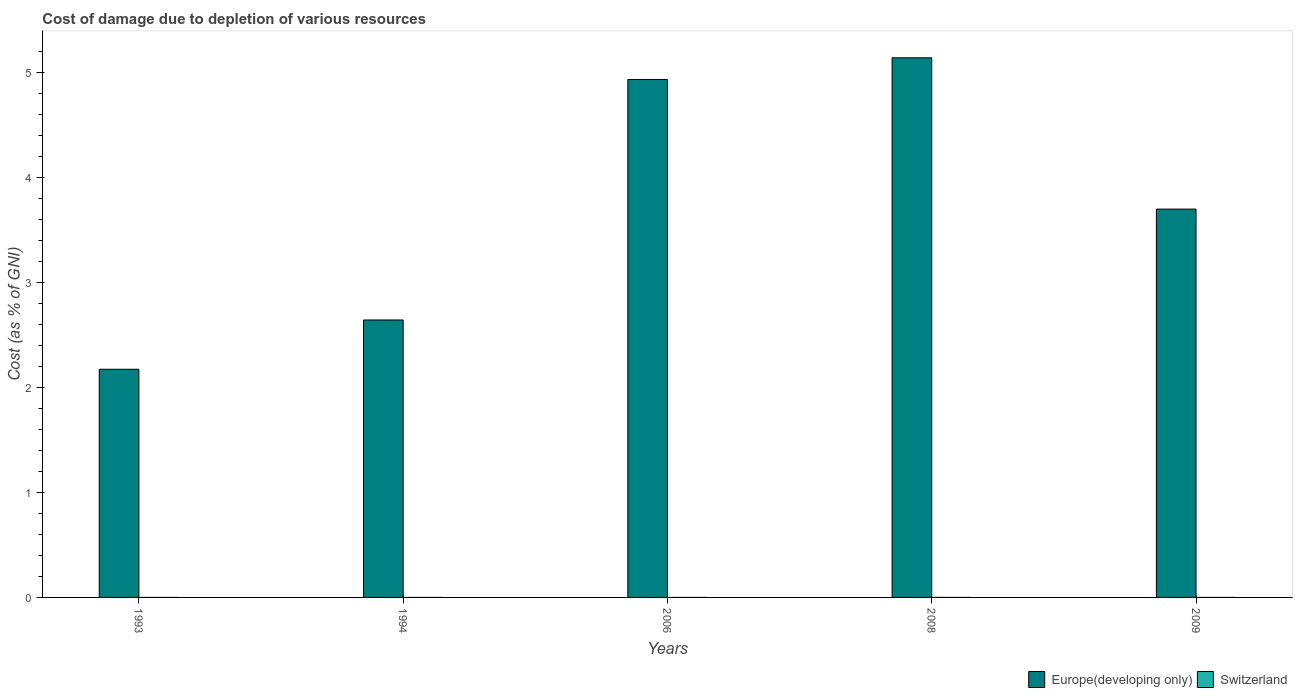Are the number of bars on each tick of the X-axis equal?
Provide a short and direct response. Yes. How many bars are there on the 4th tick from the right?
Ensure brevity in your answer.  2. What is the cost of damage caused due to the depletion of various resources in Switzerland in 1994?
Your response must be concise. 1.30474055829756e-5. Across all years, what is the maximum cost of damage caused due to the depletion of various resources in Switzerland?
Keep it short and to the point. 0. Across all years, what is the minimum cost of damage caused due to the depletion of various resources in Switzerland?
Provide a short and direct response. 1.30474055829756e-5. In which year was the cost of damage caused due to the depletion of various resources in Europe(developing only) minimum?
Provide a short and direct response. 1993. What is the total cost of damage caused due to the depletion of various resources in Europe(developing only) in the graph?
Offer a terse response. 18.57. What is the difference between the cost of damage caused due to the depletion of various resources in Europe(developing only) in 2006 and that in 2009?
Give a very brief answer. 1.23. What is the difference between the cost of damage caused due to the depletion of various resources in Switzerland in 1993 and the cost of damage caused due to the depletion of various resources in Europe(developing only) in 1994?
Your answer should be compact. -2.64. What is the average cost of damage caused due to the depletion of various resources in Europe(developing only) per year?
Give a very brief answer. 3.71. In the year 1993, what is the difference between the cost of damage caused due to the depletion of various resources in Switzerland and cost of damage caused due to the depletion of various resources in Europe(developing only)?
Keep it short and to the point. -2.17. In how many years, is the cost of damage caused due to the depletion of various resources in Switzerland greater than 2.8 %?
Give a very brief answer. 0. What is the ratio of the cost of damage caused due to the depletion of various resources in Switzerland in 1994 to that in 2008?
Provide a succinct answer. 0.09. What is the difference between the highest and the second highest cost of damage caused due to the depletion of various resources in Switzerland?
Provide a short and direct response. 6.766318279774521e-5. What is the difference between the highest and the lowest cost of damage caused due to the depletion of various resources in Switzerland?
Offer a terse response. 0. What does the 2nd bar from the left in 2009 represents?
Make the answer very short. Switzerland. What does the 2nd bar from the right in 1993 represents?
Ensure brevity in your answer.  Europe(developing only). Are all the bars in the graph horizontal?
Offer a terse response. No. What is the difference between two consecutive major ticks on the Y-axis?
Keep it short and to the point. 1. Does the graph contain grids?
Offer a very short reply. No. Where does the legend appear in the graph?
Your answer should be very brief. Bottom right. How many legend labels are there?
Offer a terse response. 2. What is the title of the graph?
Your answer should be compact. Cost of damage due to depletion of various resources. What is the label or title of the Y-axis?
Keep it short and to the point. Cost (as % of GNI). What is the Cost (as % of GNI) of Europe(developing only) in 1993?
Your answer should be very brief. 2.17. What is the Cost (as % of GNI) in Switzerland in 1993?
Offer a terse response. 3.19738165059721e-5. What is the Cost (as % of GNI) in Europe(developing only) in 1994?
Keep it short and to the point. 2.64. What is the Cost (as % of GNI) in Switzerland in 1994?
Your answer should be very brief. 1.30474055829756e-5. What is the Cost (as % of GNI) in Europe(developing only) in 2006?
Offer a terse response. 4.93. What is the Cost (as % of GNI) in Switzerland in 2006?
Your response must be concise. 3.602099116124029e-5. What is the Cost (as % of GNI) of Europe(developing only) in 2008?
Offer a terse response. 5.14. What is the Cost (as % of GNI) of Switzerland in 2008?
Provide a short and direct response. 0. What is the Cost (as % of GNI) of Europe(developing only) in 2009?
Ensure brevity in your answer.  3.7. What is the Cost (as % of GNI) of Switzerland in 2009?
Make the answer very short. 7.16161671507868e-5. Across all years, what is the maximum Cost (as % of GNI) of Europe(developing only)?
Keep it short and to the point. 5.14. Across all years, what is the maximum Cost (as % of GNI) in Switzerland?
Give a very brief answer. 0. Across all years, what is the minimum Cost (as % of GNI) of Europe(developing only)?
Give a very brief answer. 2.17. Across all years, what is the minimum Cost (as % of GNI) in Switzerland?
Your answer should be compact. 1.30474055829756e-5. What is the total Cost (as % of GNI) of Europe(developing only) in the graph?
Your answer should be very brief. 18.57. What is the total Cost (as % of GNI) in Switzerland in the graph?
Your answer should be compact. 0. What is the difference between the Cost (as % of GNI) in Europe(developing only) in 1993 and that in 1994?
Your response must be concise. -0.47. What is the difference between the Cost (as % of GNI) of Europe(developing only) in 1993 and that in 2006?
Keep it short and to the point. -2.76. What is the difference between the Cost (as % of GNI) of Europe(developing only) in 1993 and that in 2008?
Your answer should be very brief. -2.96. What is the difference between the Cost (as % of GNI) of Switzerland in 1993 and that in 2008?
Your answer should be very brief. -0. What is the difference between the Cost (as % of GNI) in Europe(developing only) in 1993 and that in 2009?
Give a very brief answer. -1.52. What is the difference between the Cost (as % of GNI) of Switzerland in 1993 and that in 2009?
Provide a short and direct response. -0. What is the difference between the Cost (as % of GNI) of Europe(developing only) in 1994 and that in 2006?
Offer a terse response. -2.29. What is the difference between the Cost (as % of GNI) of Europe(developing only) in 1994 and that in 2008?
Give a very brief answer. -2.5. What is the difference between the Cost (as % of GNI) of Switzerland in 1994 and that in 2008?
Keep it short and to the point. -0. What is the difference between the Cost (as % of GNI) in Europe(developing only) in 1994 and that in 2009?
Offer a very short reply. -1.06. What is the difference between the Cost (as % of GNI) in Switzerland in 1994 and that in 2009?
Keep it short and to the point. -0. What is the difference between the Cost (as % of GNI) in Europe(developing only) in 2006 and that in 2008?
Keep it short and to the point. -0.21. What is the difference between the Cost (as % of GNI) of Switzerland in 2006 and that in 2008?
Provide a succinct answer. -0. What is the difference between the Cost (as % of GNI) in Europe(developing only) in 2006 and that in 2009?
Your answer should be very brief. 1.23. What is the difference between the Cost (as % of GNI) of Switzerland in 2006 and that in 2009?
Offer a terse response. -0. What is the difference between the Cost (as % of GNI) in Europe(developing only) in 2008 and that in 2009?
Give a very brief answer. 1.44. What is the difference between the Cost (as % of GNI) in Europe(developing only) in 1993 and the Cost (as % of GNI) in Switzerland in 1994?
Your answer should be very brief. 2.17. What is the difference between the Cost (as % of GNI) in Europe(developing only) in 1993 and the Cost (as % of GNI) in Switzerland in 2006?
Your response must be concise. 2.17. What is the difference between the Cost (as % of GNI) of Europe(developing only) in 1993 and the Cost (as % of GNI) of Switzerland in 2008?
Provide a short and direct response. 2.17. What is the difference between the Cost (as % of GNI) of Europe(developing only) in 1993 and the Cost (as % of GNI) of Switzerland in 2009?
Your answer should be very brief. 2.17. What is the difference between the Cost (as % of GNI) in Europe(developing only) in 1994 and the Cost (as % of GNI) in Switzerland in 2006?
Ensure brevity in your answer.  2.64. What is the difference between the Cost (as % of GNI) of Europe(developing only) in 1994 and the Cost (as % of GNI) of Switzerland in 2008?
Offer a terse response. 2.64. What is the difference between the Cost (as % of GNI) of Europe(developing only) in 1994 and the Cost (as % of GNI) of Switzerland in 2009?
Your answer should be compact. 2.64. What is the difference between the Cost (as % of GNI) in Europe(developing only) in 2006 and the Cost (as % of GNI) in Switzerland in 2008?
Your response must be concise. 4.93. What is the difference between the Cost (as % of GNI) in Europe(developing only) in 2006 and the Cost (as % of GNI) in Switzerland in 2009?
Provide a short and direct response. 4.93. What is the difference between the Cost (as % of GNI) of Europe(developing only) in 2008 and the Cost (as % of GNI) of Switzerland in 2009?
Keep it short and to the point. 5.14. What is the average Cost (as % of GNI) of Europe(developing only) per year?
Your answer should be compact. 3.71. What is the average Cost (as % of GNI) in Switzerland per year?
Keep it short and to the point. 0. In the year 1993, what is the difference between the Cost (as % of GNI) of Europe(developing only) and Cost (as % of GNI) of Switzerland?
Ensure brevity in your answer.  2.17. In the year 1994, what is the difference between the Cost (as % of GNI) in Europe(developing only) and Cost (as % of GNI) in Switzerland?
Offer a terse response. 2.64. In the year 2006, what is the difference between the Cost (as % of GNI) in Europe(developing only) and Cost (as % of GNI) in Switzerland?
Provide a succinct answer. 4.93. In the year 2008, what is the difference between the Cost (as % of GNI) of Europe(developing only) and Cost (as % of GNI) of Switzerland?
Your answer should be compact. 5.14. In the year 2009, what is the difference between the Cost (as % of GNI) in Europe(developing only) and Cost (as % of GNI) in Switzerland?
Provide a succinct answer. 3.7. What is the ratio of the Cost (as % of GNI) of Europe(developing only) in 1993 to that in 1994?
Offer a very short reply. 0.82. What is the ratio of the Cost (as % of GNI) in Switzerland in 1993 to that in 1994?
Offer a very short reply. 2.45. What is the ratio of the Cost (as % of GNI) of Europe(developing only) in 1993 to that in 2006?
Your answer should be very brief. 0.44. What is the ratio of the Cost (as % of GNI) of Switzerland in 1993 to that in 2006?
Your answer should be compact. 0.89. What is the ratio of the Cost (as % of GNI) in Europe(developing only) in 1993 to that in 2008?
Give a very brief answer. 0.42. What is the ratio of the Cost (as % of GNI) of Switzerland in 1993 to that in 2008?
Provide a succinct answer. 0.23. What is the ratio of the Cost (as % of GNI) in Europe(developing only) in 1993 to that in 2009?
Provide a succinct answer. 0.59. What is the ratio of the Cost (as % of GNI) in Switzerland in 1993 to that in 2009?
Offer a terse response. 0.45. What is the ratio of the Cost (as % of GNI) of Europe(developing only) in 1994 to that in 2006?
Keep it short and to the point. 0.54. What is the ratio of the Cost (as % of GNI) of Switzerland in 1994 to that in 2006?
Your response must be concise. 0.36. What is the ratio of the Cost (as % of GNI) in Europe(developing only) in 1994 to that in 2008?
Make the answer very short. 0.51. What is the ratio of the Cost (as % of GNI) in Switzerland in 1994 to that in 2008?
Give a very brief answer. 0.09. What is the ratio of the Cost (as % of GNI) of Europe(developing only) in 1994 to that in 2009?
Give a very brief answer. 0.71. What is the ratio of the Cost (as % of GNI) in Switzerland in 1994 to that in 2009?
Give a very brief answer. 0.18. What is the ratio of the Cost (as % of GNI) of Europe(developing only) in 2006 to that in 2008?
Give a very brief answer. 0.96. What is the ratio of the Cost (as % of GNI) in Switzerland in 2006 to that in 2008?
Give a very brief answer. 0.26. What is the ratio of the Cost (as % of GNI) of Europe(developing only) in 2006 to that in 2009?
Keep it short and to the point. 1.33. What is the ratio of the Cost (as % of GNI) in Switzerland in 2006 to that in 2009?
Provide a succinct answer. 0.5. What is the ratio of the Cost (as % of GNI) of Europe(developing only) in 2008 to that in 2009?
Offer a terse response. 1.39. What is the ratio of the Cost (as % of GNI) of Switzerland in 2008 to that in 2009?
Make the answer very short. 1.94. What is the difference between the highest and the second highest Cost (as % of GNI) of Europe(developing only)?
Keep it short and to the point. 0.21. What is the difference between the highest and the lowest Cost (as % of GNI) in Europe(developing only)?
Give a very brief answer. 2.96. 